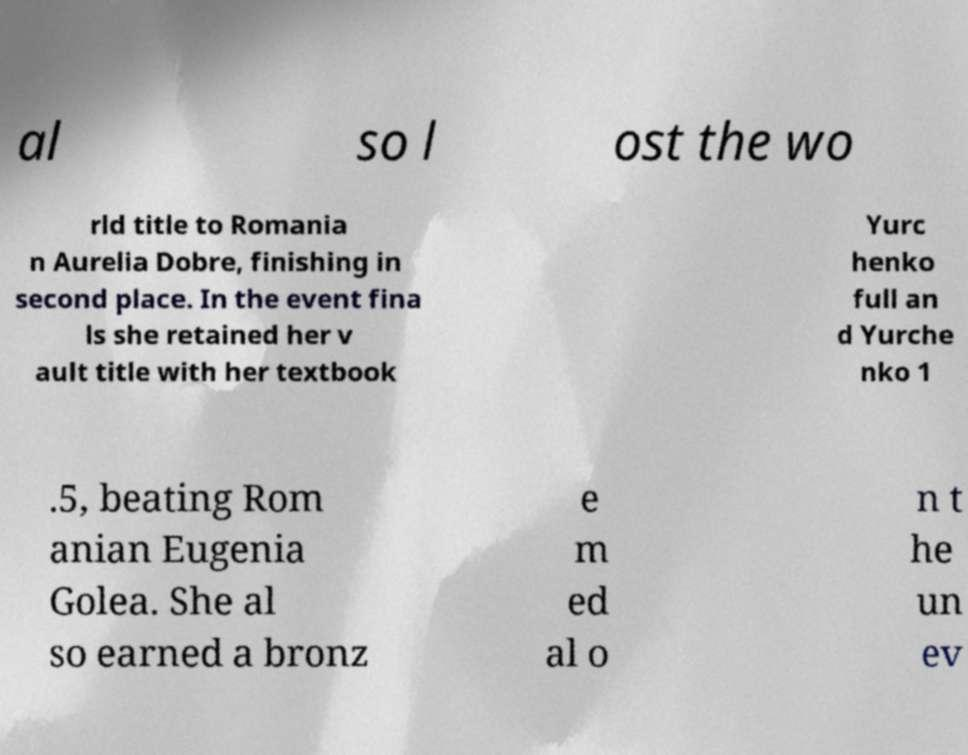Could you extract and type out the text from this image? al so l ost the wo rld title to Romania n Aurelia Dobre, finishing in second place. In the event fina ls she retained her v ault title with her textbook Yurc henko full an d Yurche nko 1 .5, beating Rom anian Eugenia Golea. She al so earned a bronz e m ed al o n t he un ev 